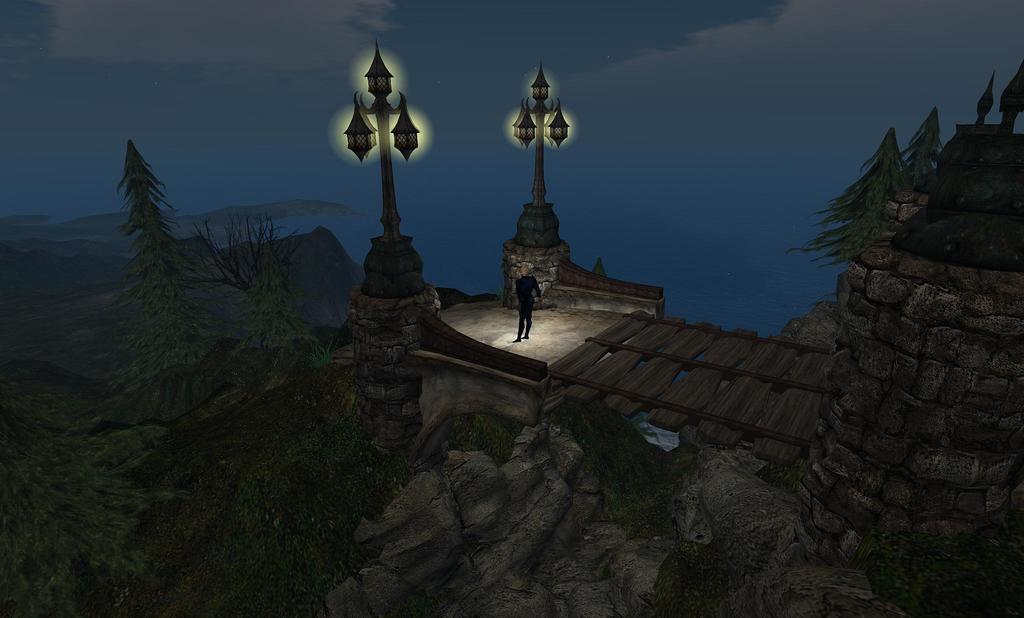Please provide a concise description of this image. In the image we can see there is an animation picture in which there is a person standing on the building and there are lot of trees. There are street light poles. 